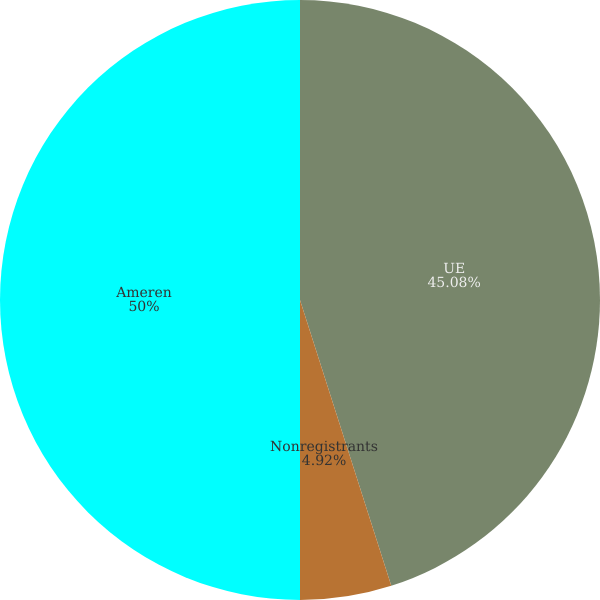Convert chart to OTSL. <chart><loc_0><loc_0><loc_500><loc_500><pie_chart><fcel>UE<fcel>Nonregistrants<fcel>Ameren<nl><fcel>45.08%<fcel>4.92%<fcel>50.0%<nl></chart> 